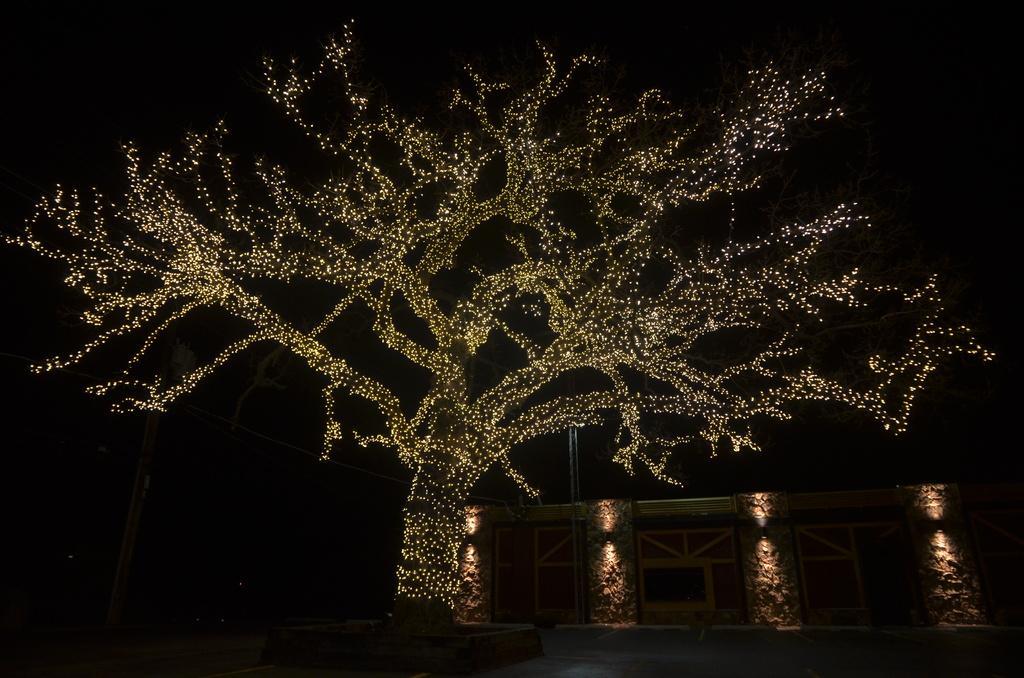Could you give a brief overview of what you see in this image? In this image we can see a wall, poles, wires, and lights. Here we can see a tree decorated with lights. There is a dark background. 